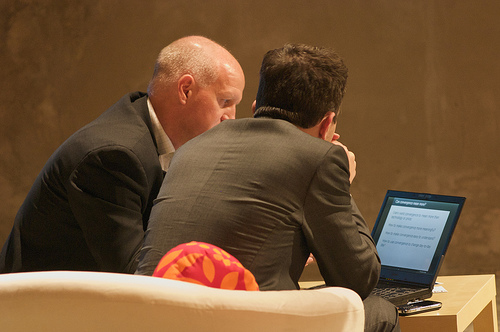How many cushions are in the photo? There is one brightly patterned cushion situated on a white couch in the photo. 